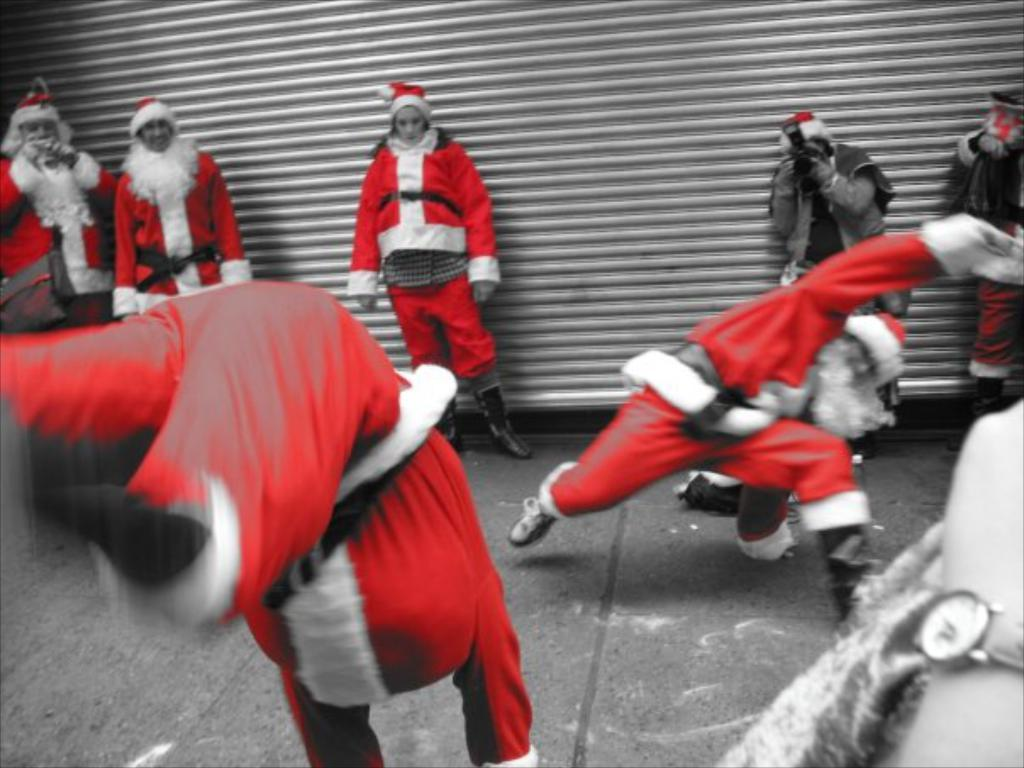What is the main feature of the image? There is a road in the image. What are the two people in the image doing? Two people are dancing in the image. Are there any other people present in the image? Yes, there are other people standing in the background, watching the dancing. What can be seen in the background of the image? There is a roller shutter in the background of the image. What type of haircut is the person in the background getting? There is no person getting a haircut in the image; the focus is on the dancing and the roller shutter in the background. 